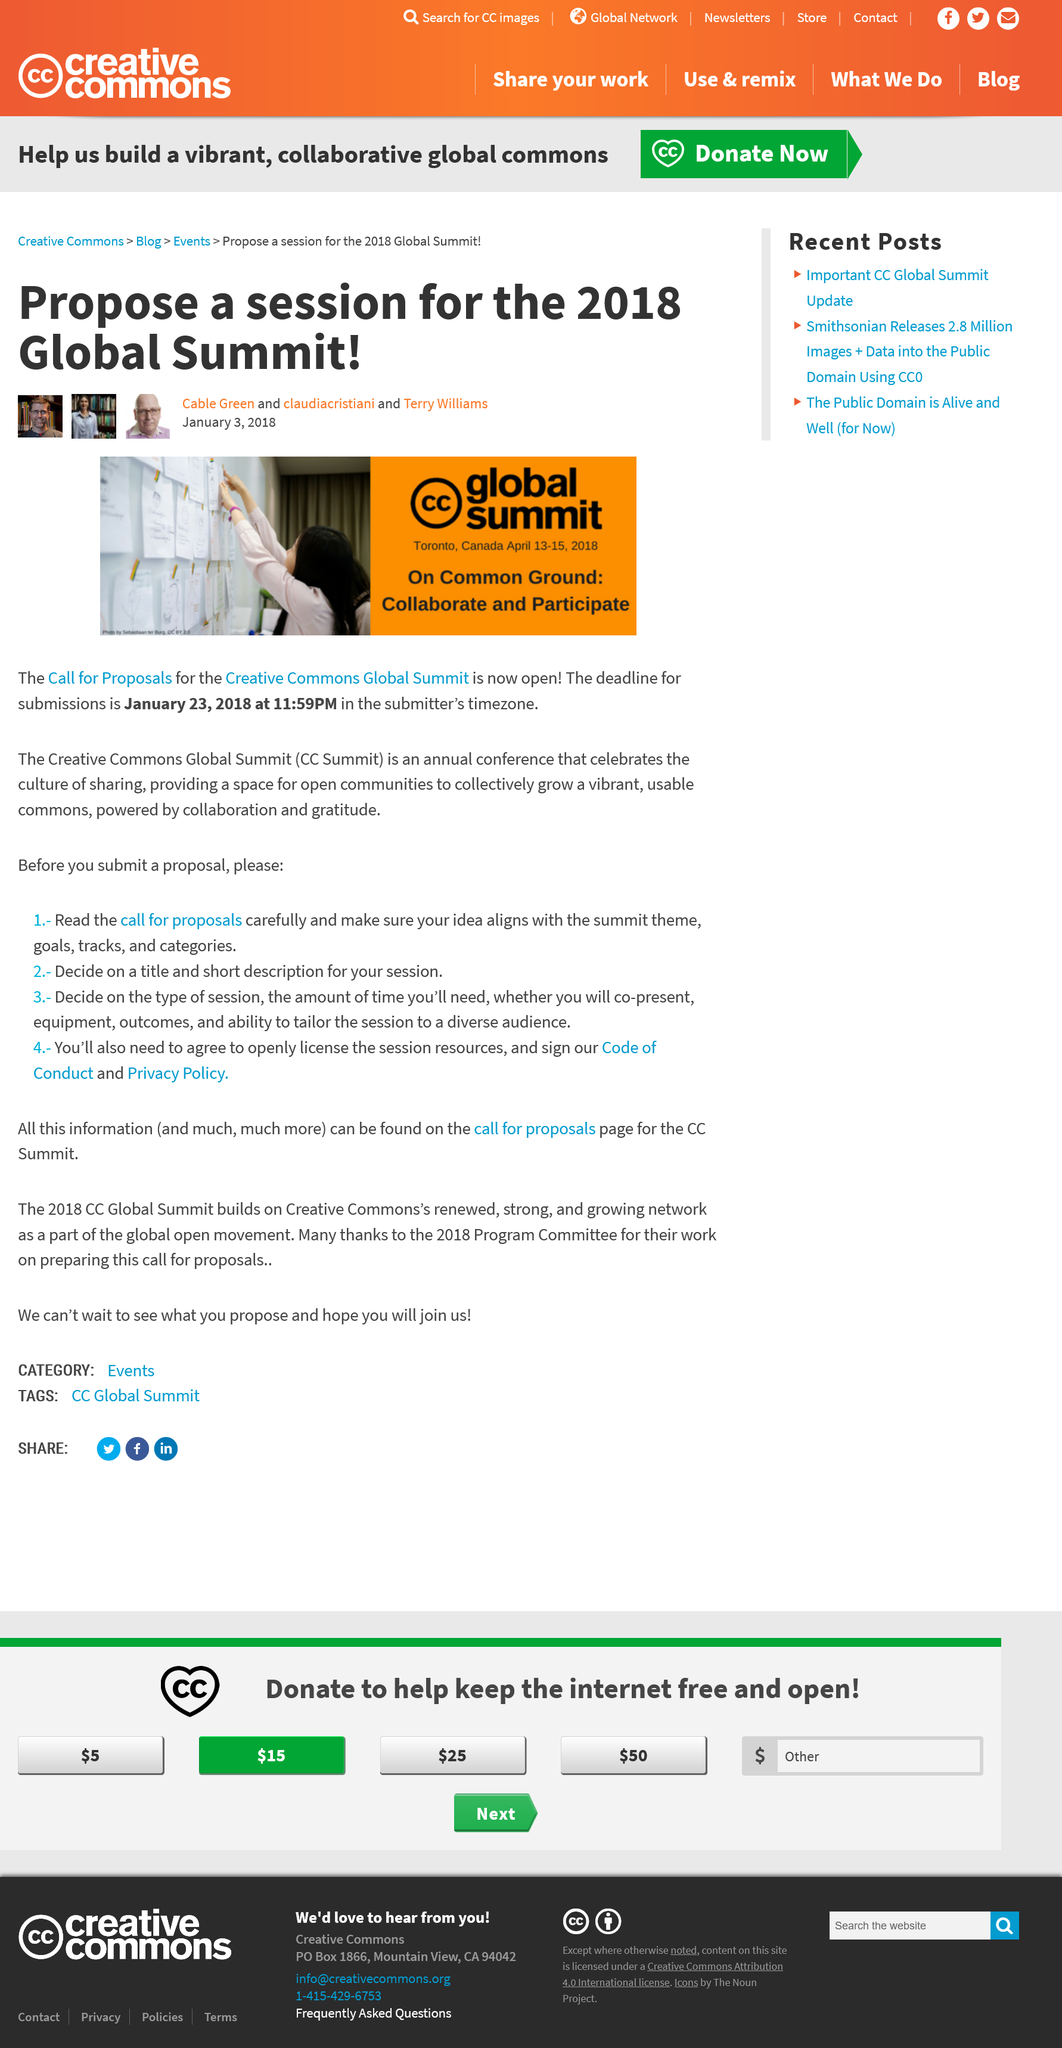Identify some key points in this picture. There are 20 days remaining until the deadline. The CC Summit is an annual conference that takes place How often? The CC Summit takes place in Toronto, Canada. 